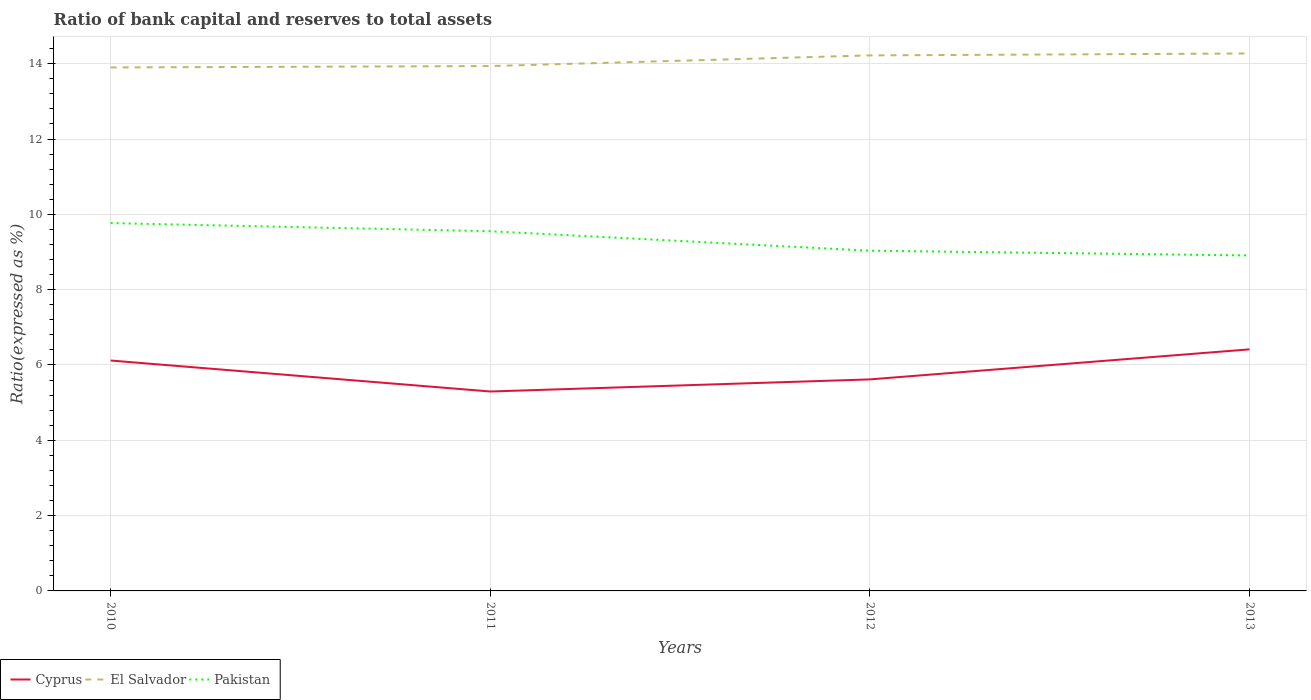How many different coloured lines are there?
Offer a very short reply. 3. Across all years, what is the maximum ratio of bank capital and reserves to total assets in Pakistan?
Provide a succinct answer. 8.91. In which year was the ratio of bank capital and reserves to total assets in Cyprus maximum?
Provide a short and direct response. 2011. What is the total ratio of bank capital and reserves to total assets in Pakistan in the graph?
Ensure brevity in your answer.  0.73. What is the difference between the highest and the second highest ratio of bank capital and reserves to total assets in El Salvador?
Offer a very short reply. 0.37. How many lines are there?
Keep it short and to the point. 3. How many years are there in the graph?
Ensure brevity in your answer.  4. Are the values on the major ticks of Y-axis written in scientific E-notation?
Ensure brevity in your answer.  No. Does the graph contain any zero values?
Ensure brevity in your answer.  No. Does the graph contain grids?
Your answer should be compact. Yes. How many legend labels are there?
Provide a short and direct response. 3. How are the legend labels stacked?
Provide a succinct answer. Horizontal. What is the title of the graph?
Ensure brevity in your answer.  Ratio of bank capital and reserves to total assets. What is the label or title of the Y-axis?
Offer a very short reply. Ratio(expressed as %). What is the Ratio(expressed as %) of Cyprus in 2010?
Ensure brevity in your answer.  6.12. What is the Ratio(expressed as %) of Pakistan in 2010?
Keep it short and to the point. 9.77. What is the Ratio(expressed as %) of Cyprus in 2011?
Your response must be concise. 5.3. What is the Ratio(expressed as %) in El Salvador in 2011?
Make the answer very short. 13.94. What is the Ratio(expressed as %) in Pakistan in 2011?
Offer a terse response. 9.55. What is the Ratio(expressed as %) in Cyprus in 2012?
Make the answer very short. 5.62. What is the Ratio(expressed as %) in El Salvador in 2012?
Make the answer very short. 14.22. What is the Ratio(expressed as %) in Pakistan in 2012?
Your answer should be very brief. 9.03. What is the Ratio(expressed as %) of Cyprus in 2013?
Ensure brevity in your answer.  6.41. What is the Ratio(expressed as %) of El Salvador in 2013?
Offer a very short reply. 14.27. What is the Ratio(expressed as %) in Pakistan in 2013?
Your answer should be very brief. 8.91. Across all years, what is the maximum Ratio(expressed as %) in Cyprus?
Keep it short and to the point. 6.41. Across all years, what is the maximum Ratio(expressed as %) of El Salvador?
Give a very brief answer. 14.27. Across all years, what is the maximum Ratio(expressed as %) of Pakistan?
Make the answer very short. 9.77. Across all years, what is the minimum Ratio(expressed as %) of Cyprus?
Offer a terse response. 5.3. Across all years, what is the minimum Ratio(expressed as %) of El Salvador?
Offer a very short reply. 13.9. Across all years, what is the minimum Ratio(expressed as %) in Pakistan?
Offer a terse response. 8.91. What is the total Ratio(expressed as %) in Cyprus in the graph?
Offer a very short reply. 23.45. What is the total Ratio(expressed as %) of El Salvador in the graph?
Make the answer very short. 56.33. What is the total Ratio(expressed as %) of Pakistan in the graph?
Offer a terse response. 37.26. What is the difference between the Ratio(expressed as %) in Cyprus in 2010 and that in 2011?
Ensure brevity in your answer.  0.82. What is the difference between the Ratio(expressed as %) of El Salvador in 2010 and that in 2011?
Give a very brief answer. -0.04. What is the difference between the Ratio(expressed as %) of Pakistan in 2010 and that in 2011?
Offer a very short reply. 0.22. What is the difference between the Ratio(expressed as %) of Cyprus in 2010 and that in 2012?
Keep it short and to the point. 0.5. What is the difference between the Ratio(expressed as %) in El Salvador in 2010 and that in 2012?
Ensure brevity in your answer.  -0.32. What is the difference between the Ratio(expressed as %) of Pakistan in 2010 and that in 2012?
Give a very brief answer. 0.73. What is the difference between the Ratio(expressed as %) in Cyprus in 2010 and that in 2013?
Your answer should be compact. -0.3. What is the difference between the Ratio(expressed as %) in El Salvador in 2010 and that in 2013?
Keep it short and to the point. -0.37. What is the difference between the Ratio(expressed as %) of Pakistan in 2010 and that in 2013?
Your answer should be very brief. 0.86. What is the difference between the Ratio(expressed as %) of Cyprus in 2011 and that in 2012?
Offer a very short reply. -0.32. What is the difference between the Ratio(expressed as %) in El Salvador in 2011 and that in 2012?
Offer a very short reply. -0.28. What is the difference between the Ratio(expressed as %) of Pakistan in 2011 and that in 2012?
Make the answer very short. 0.52. What is the difference between the Ratio(expressed as %) of Cyprus in 2011 and that in 2013?
Provide a succinct answer. -1.12. What is the difference between the Ratio(expressed as %) of El Salvador in 2011 and that in 2013?
Make the answer very short. -0.33. What is the difference between the Ratio(expressed as %) in Pakistan in 2011 and that in 2013?
Ensure brevity in your answer.  0.64. What is the difference between the Ratio(expressed as %) of Cyprus in 2012 and that in 2013?
Provide a short and direct response. -0.8. What is the difference between the Ratio(expressed as %) in El Salvador in 2012 and that in 2013?
Provide a short and direct response. -0.05. What is the difference between the Ratio(expressed as %) in Pakistan in 2012 and that in 2013?
Ensure brevity in your answer.  0.13. What is the difference between the Ratio(expressed as %) in Cyprus in 2010 and the Ratio(expressed as %) in El Salvador in 2011?
Give a very brief answer. -7.82. What is the difference between the Ratio(expressed as %) of Cyprus in 2010 and the Ratio(expressed as %) of Pakistan in 2011?
Offer a very short reply. -3.43. What is the difference between the Ratio(expressed as %) of El Salvador in 2010 and the Ratio(expressed as %) of Pakistan in 2011?
Offer a terse response. 4.35. What is the difference between the Ratio(expressed as %) of Cyprus in 2010 and the Ratio(expressed as %) of El Salvador in 2012?
Offer a very short reply. -8.1. What is the difference between the Ratio(expressed as %) in Cyprus in 2010 and the Ratio(expressed as %) in Pakistan in 2012?
Keep it short and to the point. -2.92. What is the difference between the Ratio(expressed as %) of El Salvador in 2010 and the Ratio(expressed as %) of Pakistan in 2012?
Your answer should be compact. 4.87. What is the difference between the Ratio(expressed as %) in Cyprus in 2010 and the Ratio(expressed as %) in El Salvador in 2013?
Offer a terse response. -8.15. What is the difference between the Ratio(expressed as %) of Cyprus in 2010 and the Ratio(expressed as %) of Pakistan in 2013?
Provide a succinct answer. -2.79. What is the difference between the Ratio(expressed as %) of El Salvador in 2010 and the Ratio(expressed as %) of Pakistan in 2013?
Provide a short and direct response. 4.99. What is the difference between the Ratio(expressed as %) of Cyprus in 2011 and the Ratio(expressed as %) of El Salvador in 2012?
Give a very brief answer. -8.92. What is the difference between the Ratio(expressed as %) of Cyprus in 2011 and the Ratio(expressed as %) of Pakistan in 2012?
Offer a terse response. -3.74. What is the difference between the Ratio(expressed as %) in El Salvador in 2011 and the Ratio(expressed as %) in Pakistan in 2012?
Offer a terse response. 4.9. What is the difference between the Ratio(expressed as %) in Cyprus in 2011 and the Ratio(expressed as %) in El Salvador in 2013?
Your answer should be very brief. -8.98. What is the difference between the Ratio(expressed as %) in Cyprus in 2011 and the Ratio(expressed as %) in Pakistan in 2013?
Offer a very short reply. -3.61. What is the difference between the Ratio(expressed as %) of El Salvador in 2011 and the Ratio(expressed as %) of Pakistan in 2013?
Your answer should be compact. 5.03. What is the difference between the Ratio(expressed as %) in Cyprus in 2012 and the Ratio(expressed as %) in El Salvador in 2013?
Offer a terse response. -8.65. What is the difference between the Ratio(expressed as %) in Cyprus in 2012 and the Ratio(expressed as %) in Pakistan in 2013?
Your response must be concise. -3.29. What is the difference between the Ratio(expressed as %) of El Salvador in 2012 and the Ratio(expressed as %) of Pakistan in 2013?
Your response must be concise. 5.31. What is the average Ratio(expressed as %) in Cyprus per year?
Your answer should be very brief. 5.86. What is the average Ratio(expressed as %) in El Salvador per year?
Make the answer very short. 14.08. What is the average Ratio(expressed as %) of Pakistan per year?
Give a very brief answer. 9.32. In the year 2010, what is the difference between the Ratio(expressed as %) in Cyprus and Ratio(expressed as %) in El Salvador?
Your response must be concise. -7.78. In the year 2010, what is the difference between the Ratio(expressed as %) in Cyprus and Ratio(expressed as %) in Pakistan?
Keep it short and to the point. -3.65. In the year 2010, what is the difference between the Ratio(expressed as %) of El Salvador and Ratio(expressed as %) of Pakistan?
Make the answer very short. 4.13. In the year 2011, what is the difference between the Ratio(expressed as %) of Cyprus and Ratio(expressed as %) of El Salvador?
Provide a short and direct response. -8.64. In the year 2011, what is the difference between the Ratio(expressed as %) in Cyprus and Ratio(expressed as %) in Pakistan?
Your response must be concise. -4.26. In the year 2011, what is the difference between the Ratio(expressed as %) in El Salvador and Ratio(expressed as %) in Pakistan?
Your answer should be very brief. 4.39. In the year 2012, what is the difference between the Ratio(expressed as %) in Cyprus and Ratio(expressed as %) in El Salvador?
Keep it short and to the point. -8.6. In the year 2012, what is the difference between the Ratio(expressed as %) of Cyprus and Ratio(expressed as %) of Pakistan?
Offer a terse response. -3.42. In the year 2012, what is the difference between the Ratio(expressed as %) in El Salvador and Ratio(expressed as %) in Pakistan?
Offer a very short reply. 5.19. In the year 2013, what is the difference between the Ratio(expressed as %) in Cyprus and Ratio(expressed as %) in El Salvador?
Your response must be concise. -7.86. In the year 2013, what is the difference between the Ratio(expressed as %) in Cyprus and Ratio(expressed as %) in Pakistan?
Ensure brevity in your answer.  -2.49. In the year 2013, what is the difference between the Ratio(expressed as %) of El Salvador and Ratio(expressed as %) of Pakistan?
Keep it short and to the point. 5.36. What is the ratio of the Ratio(expressed as %) of Cyprus in 2010 to that in 2011?
Your answer should be very brief. 1.16. What is the ratio of the Ratio(expressed as %) of Pakistan in 2010 to that in 2011?
Provide a short and direct response. 1.02. What is the ratio of the Ratio(expressed as %) in Cyprus in 2010 to that in 2012?
Your response must be concise. 1.09. What is the ratio of the Ratio(expressed as %) of El Salvador in 2010 to that in 2012?
Your answer should be very brief. 0.98. What is the ratio of the Ratio(expressed as %) in Pakistan in 2010 to that in 2012?
Offer a terse response. 1.08. What is the ratio of the Ratio(expressed as %) of Cyprus in 2010 to that in 2013?
Make the answer very short. 0.95. What is the ratio of the Ratio(expressed as %) in El Salvador in 2010 to that in 2013?
Your response must be concise. 0.97. What is the ratio of the Ratio(expressed as %) in Pakistan in 2010 to that in 2013?
Offer a very short reply. 1.1. What is the ratio of the Ratio(expressed as %) of Cyprus in 2011 to that in 2012?
Your answer should be compact. 0.94. What is the ratio of the Ratio(expressed as %) of El Salvador in 2011 to that in 2012?
Provide a short and direct response. 0.98. What is the ratio of the Ratio(expressed as %) of Pakistan in 2011 to that in 2012?
Make the answer very short. 1.06. What is the ratio of the Ratio(expressed as %) of Cyprus in 2011 to that in 2013?
Give a very brief answer. 0.83. What is the ratio of the Ratio(expressed as %) in El Salvador in 2011 to that in 2013?
Your response must be concise. 0.98. What is the ratio of the Ratio(expressed as %) in Pakistan in 2011 to that in 2013?
Offer a terse response. 1.07. What is the ratio of the Ratio(expressed as %) in Cyprus in 2012 to that in 2013?
Your answer should be compact. 0.88. What is the ratio of the Ratio(expressed as %) of El Salvador in 2012 to that in 2013?
Offer a very short reply. 1. What is the ratio of the Ratio(expressed as %) in Pakistan in 2012 to that in 2013?
Give a very brief answer. 1.01. What is the difference between the highest and the second highest Ratio(expressed as %) in Cyprus?
Offer a terse response. 0.3. What is the difference between the highest and the second highest Ratio(expressed as %) in El Salvador?
Your answer should be compact. 0.05. What is the difference between the highest and the second highest Ratio(expressed as %) in Pakistan?
Make the answer very short. 0.22. What is the difference between the highest and the lowest Ratio(expressed as %) in Cyprus?
Ensure brevity in your answer.  1.12. What is the difference between the highest and the lowest Ratio(expressed as %) in El Salvador?
Your answer should be compact. 0.37. What is the difference between the highest and the lowest Ratio(expressed as %) in Pakistan?
Give a very brief answer. 0.86. 